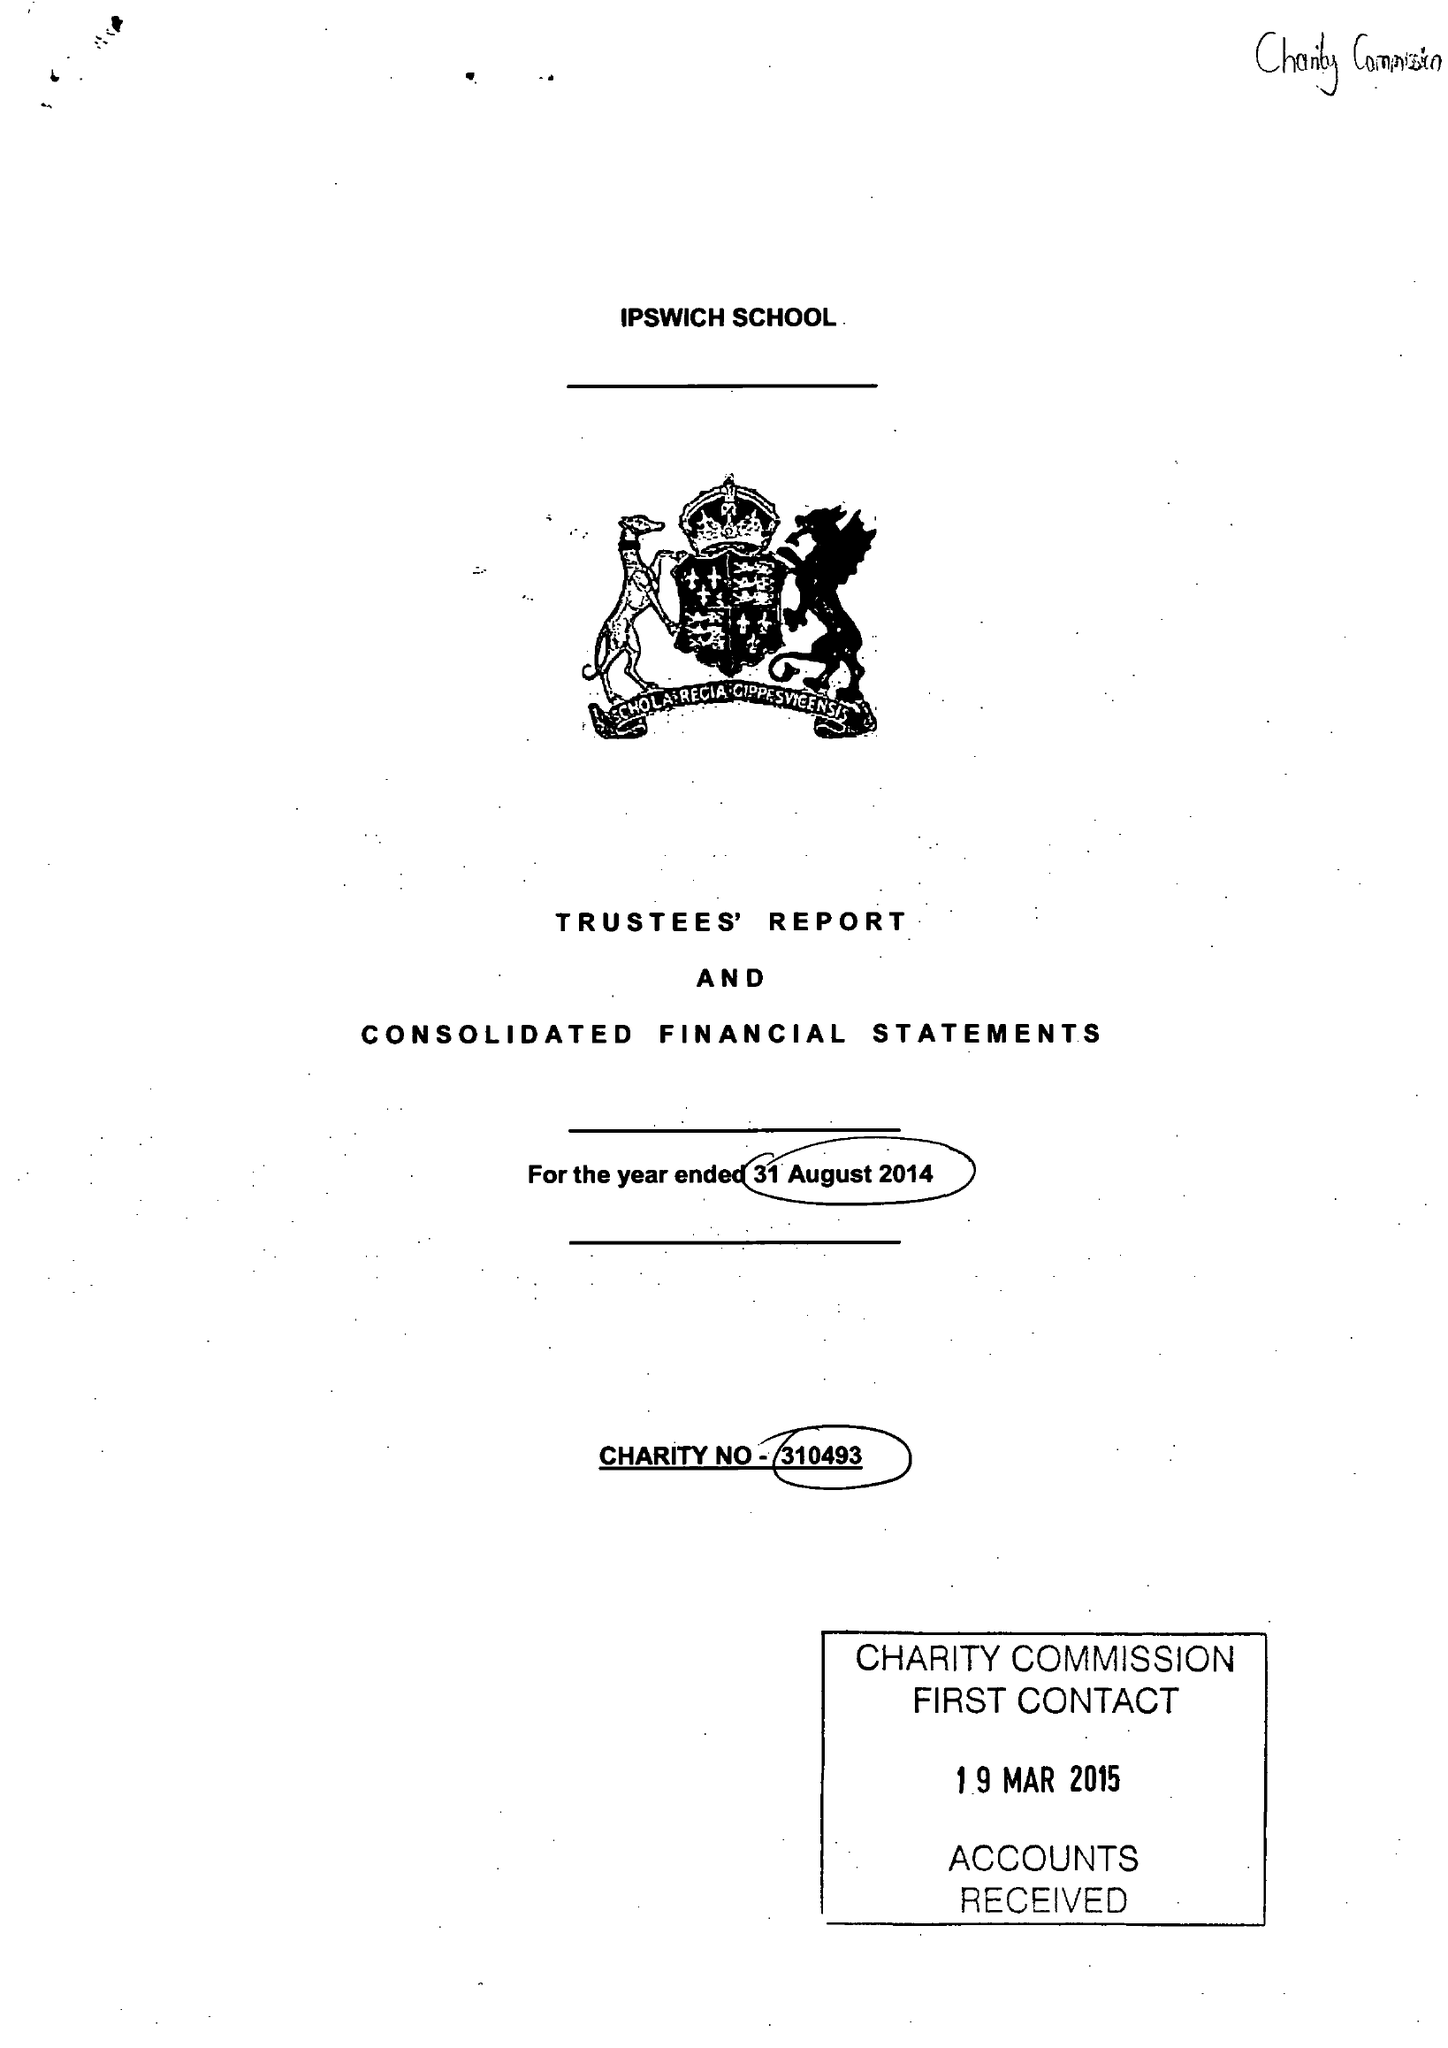What is the value for the address__postcode?
Answer the question using a single word or phrase. IP1 3SG 